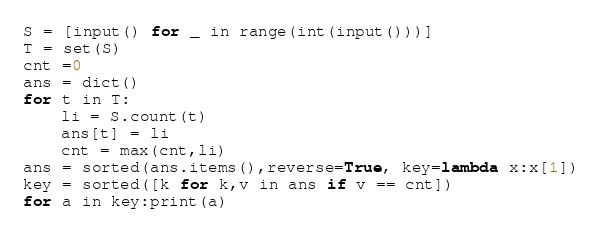<code> <loc_0><loc_0><loc_500><loc_500><_Python_>S = [input() for _ in range(int(input()))]
T = set(S)
cnt =0
ans = dict()
for t in T:
    li = S.count(t)
    ans[t] = li
    cnt = max(cnt,li)
ans = sorted(ans.items(),reverse=True, key=lambda x:x[1])
key = sorted([k for k,v in ans if v == cnt])
for a in key:print(a)</code> 